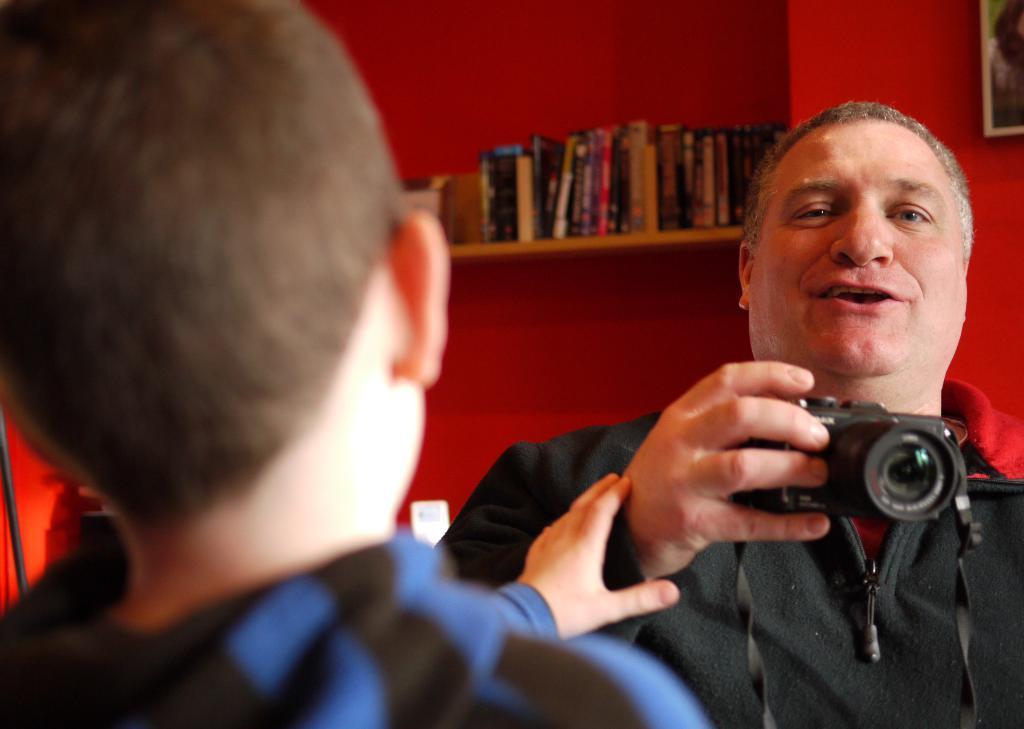Can you describe this image briefly? In this image there are persons. In the center there is a man holding a camera in his hand and having some expression on his face. In the background there is a shelf and on the shelf there are objects and there is a frame on the wall and the wall is red in colour. 